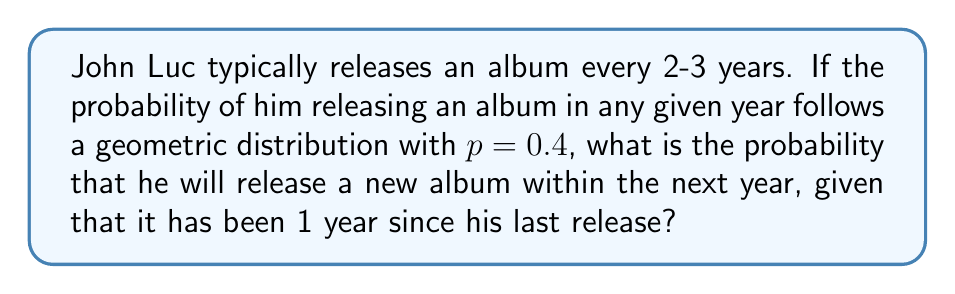Can you answer this question? Let's approach this step-by-step:

1) The geometric distribution models the probability of the first success occurring on the $n$-th trial. In this case, "success" is releasing an album.

2) We're given that $p = 0.4$, which means there's a 40% chance of John Luc releasing an album in any given year.

3) We want to find the probability of success on the 2nd trial (next year), given that the 1st trial (this year) was a failure.

4) This is a conditional probability problem. We can use the formula:

   $P(X = 2 | X > 1) = \frac{P(X = 2)}{P(X > 1)}$

5) For a geometric distribution:
   $P(X = k) = (1-p)^{k-1} \cdot p$

6) So, $P(X = 2) = (1-0.4)^{2-1} \cdot 0.4 = 0.6 \cdot 0.4 = 0.24$

7) And $P(X > 1) = 1 - P(X = 1) = 1 - 0.4 = 0.6$

8) Substituting into our conditional probability formula:

   $P(X = 2 | X > 1) = \frac{0.24}{0.6} = 0.4$

Therefore, the probability of John Luc releasing an album next year, given that he didn't release one this year, is 0.4 or 40%.
Answer: 0.4 